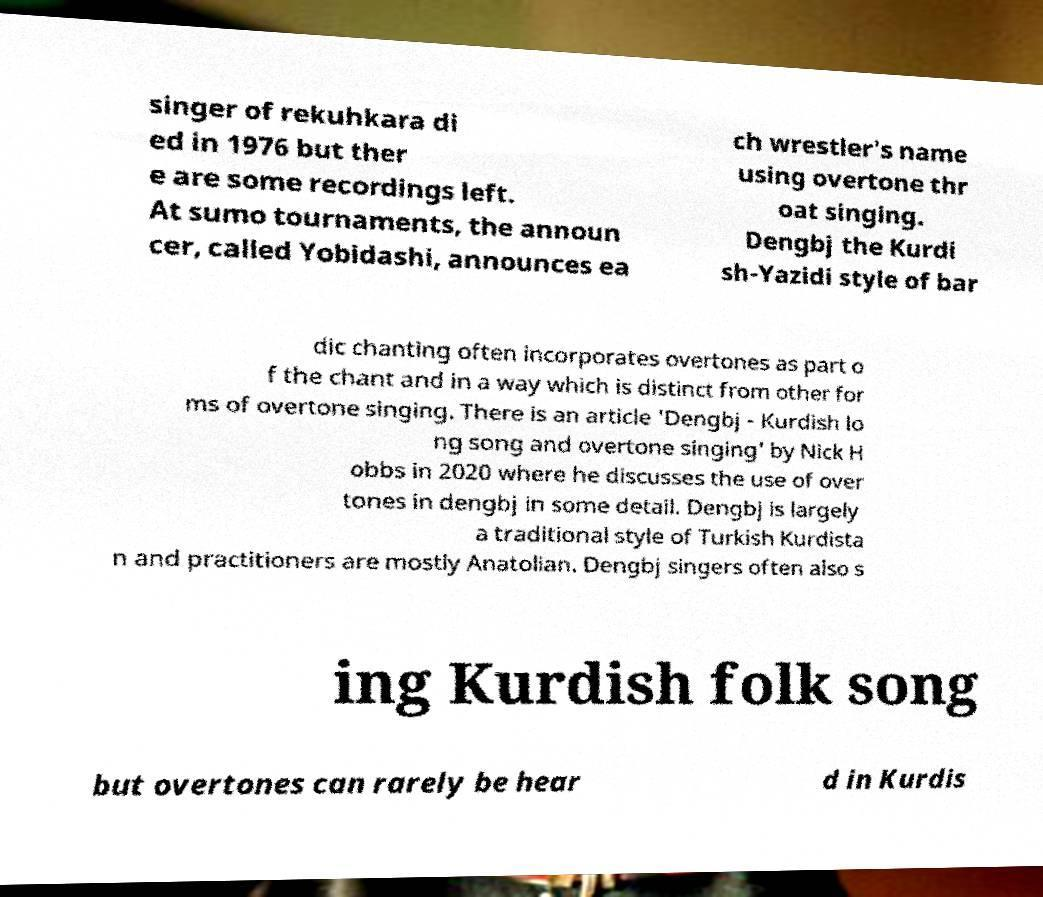There's text embedded in this image that I need extracted. Can you transcribe it verbatim? singer of rekuhkara di ed in 1976 but ther e are some recordings left. At sumo tournaments, the announ cer, called Yobidashi, announces ea ch wrestler's name using overtone thr oat singing. Dengbj the Kurdi sh-Yazidi style of bar dic chanting often incorporates overtones as part o f the chant and in a way which is distinct from other for ms of overtone singing. There is an article 'Dengbj - Kurdish lo ng song and overtone singing' by Nick H obbs in 2020 where he discusses the use of over tones in dengbj in some detail. Dengbj is largely a traditional style of Turkish Kurdista n and practitioners are mostly Anatolian. Dengbj singers often also s ing Kurdish folk song but overtones can rarely be hear d in Kurdis 